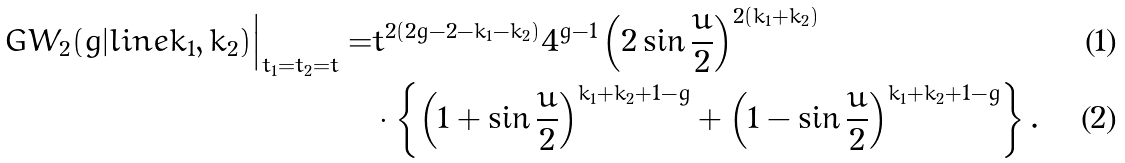Convert formula to latex. <formula><loc_0><loc_0><loc_500><loc_500>G W _ { 2 } ( g | l i n e k _ { 1 } , k _ { 2 } ) \Big | _ { t _ { 1 } = t _ { 2 } = t } = & t ^ { 2 ( 2 g - 2 - k _ { 1 } - k _ { 2 } ) } 4 ^ { g - 1 } \left ( 2 \sin \frac { u } { 2 } \right ) ^ { 2 ( k _ { 1 } + k _ { 2 } ) } \\ & \cdot \left \{ \left ( 1 + \sin \frac { u } { 2 } \right ) ^ { k _ { 1 } + k _ { 2 } + 1 - g } + \left ( 1 - \sin \frac { u } { 2 } \right ) ^ { k _ { 1 } + k _ { 2 } + 1 - g } \right \} .</formula> 